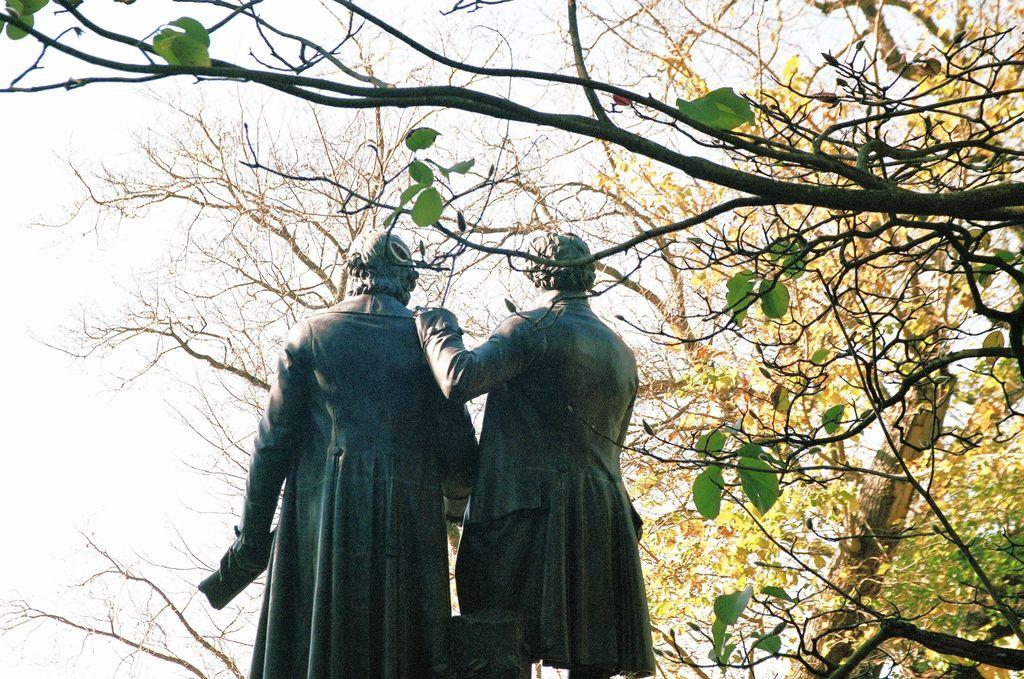How many statues are present in the image? There are two statues in the image. What is the surrounding environment of the statues? There are trees with branches and leaves around the statues. What type of pollution is visible in the image? There is no visible pollution in the image; it only features two statues and trees with branches and leaves. 